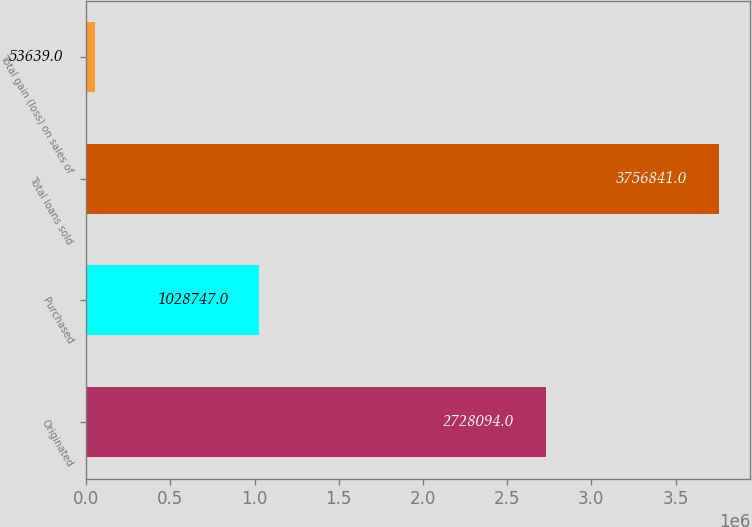Convert chart to OTSL. <chart><loc_0><loc_0><loc_500><loc_500><bar_chart><fcel>Originated<fcel>Purchased<fcel>Total loans sold<fcel>Total gain (loss) on sales of<nl><fcel>2.72809e+06<fcel>1.02875e+06<fcel>3.75684e+06<fcel>53639<nl></chart> 